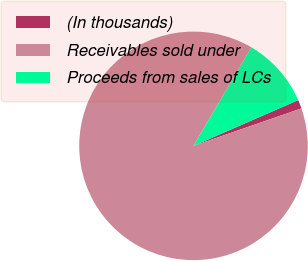<chart> <loc_0><loc_0><loc_500><loc_500><pie_chart><fcel>(In thousands)<fcel>Receivables sold under<fcel>Proceeds from sales of LCs<nl><fcel>1.24%<fcel>88.77%<fcel>9.99%<nl></chart> 